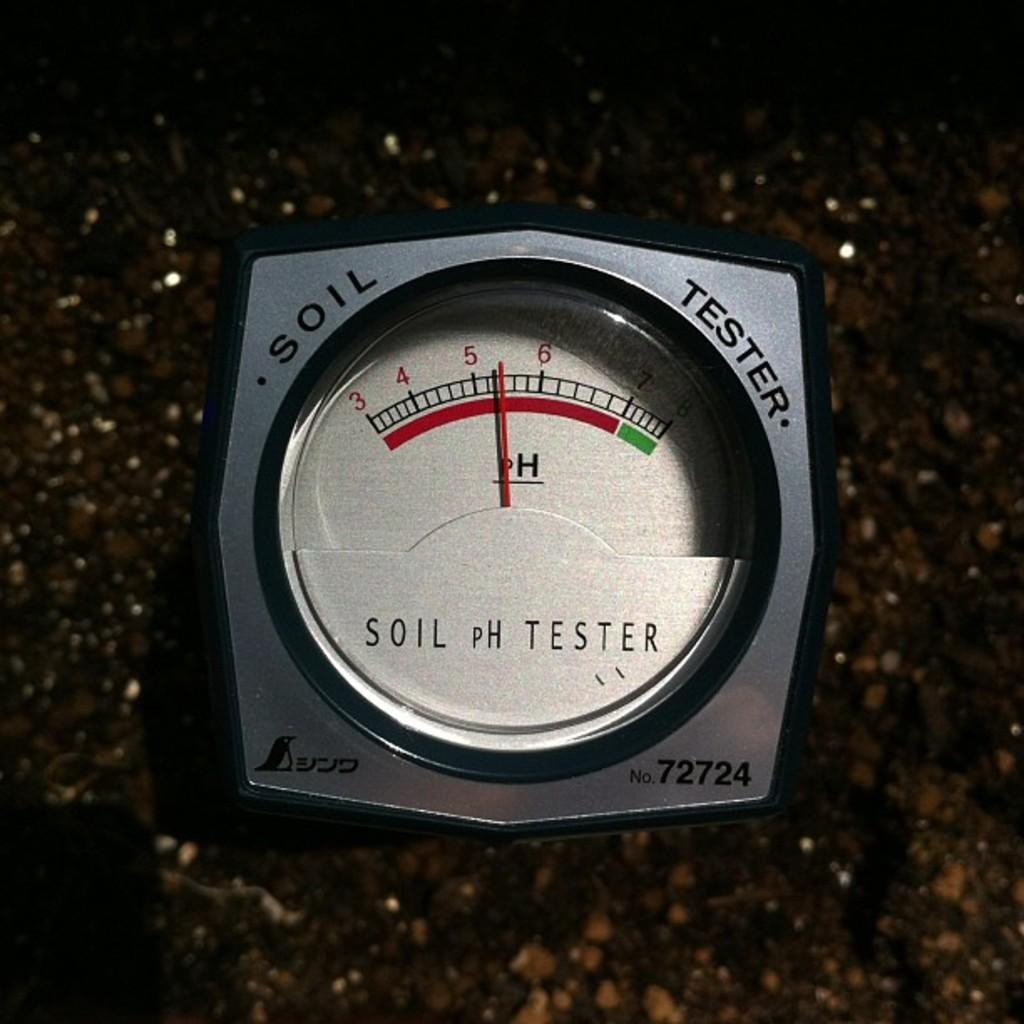What is the main object in the image? There is a soil tester machine in the image. What can be seen at the bottom of the image? The floor is visible at the bottom of the image. What type of brass instrument is being played in the image? There is no brass instrument present in the image; it features a soil tester machine. How does the bit affect the soil tester machine's performance in the image? There is no bit mentioned or visible in the image, as it only shows a soil tester machine. 